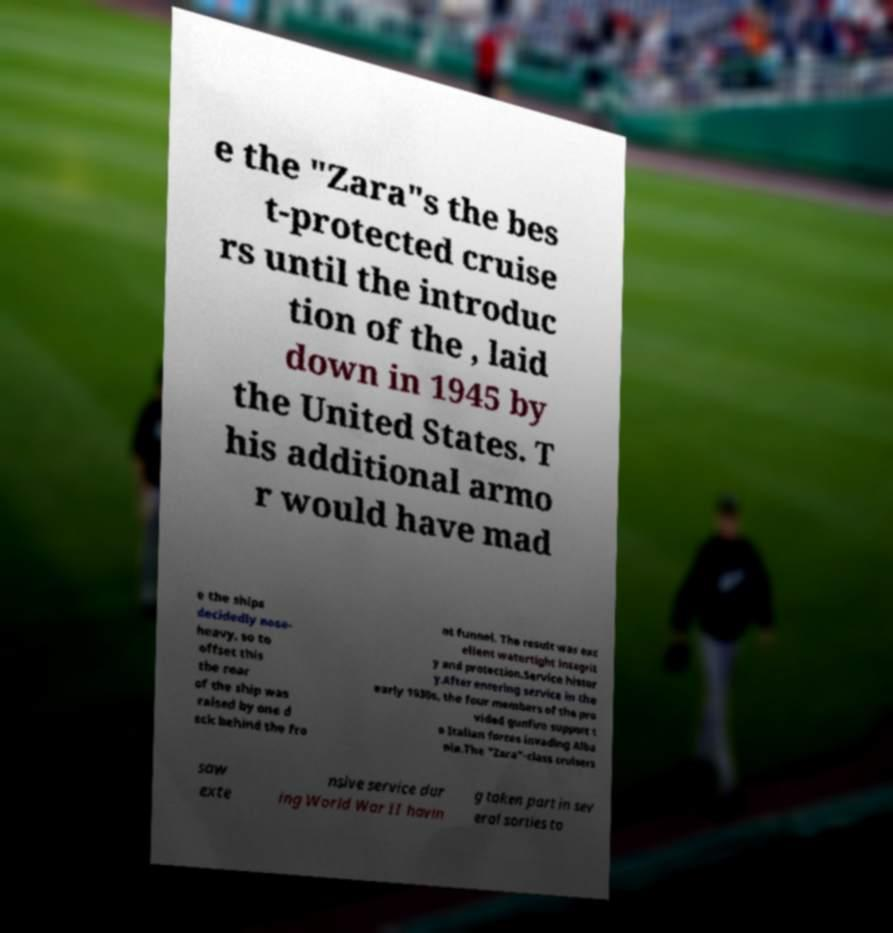There's text embedded in this image that I need extracted. Can you transcribe it verbatim? e the "Zara"s the bes t-protected cruise rs until the introduc tion of the , laid down in 1945 by the United States. T his additional armo r would have mad e the ships decidedly nose- heavy, so to offset this the rear of the ship was raised by one d eck behind the fro nt funnel. The result was exc ellent watertight integrit y and protection.Service histor y.After entering service in the early 1930s, the four members of the pro vided gunfire support t o Italian forces invading Alba nia.The "Zara"-class cruisers saw exte nsive service dur ing World War II havin g taken part in sev eral sorties to 